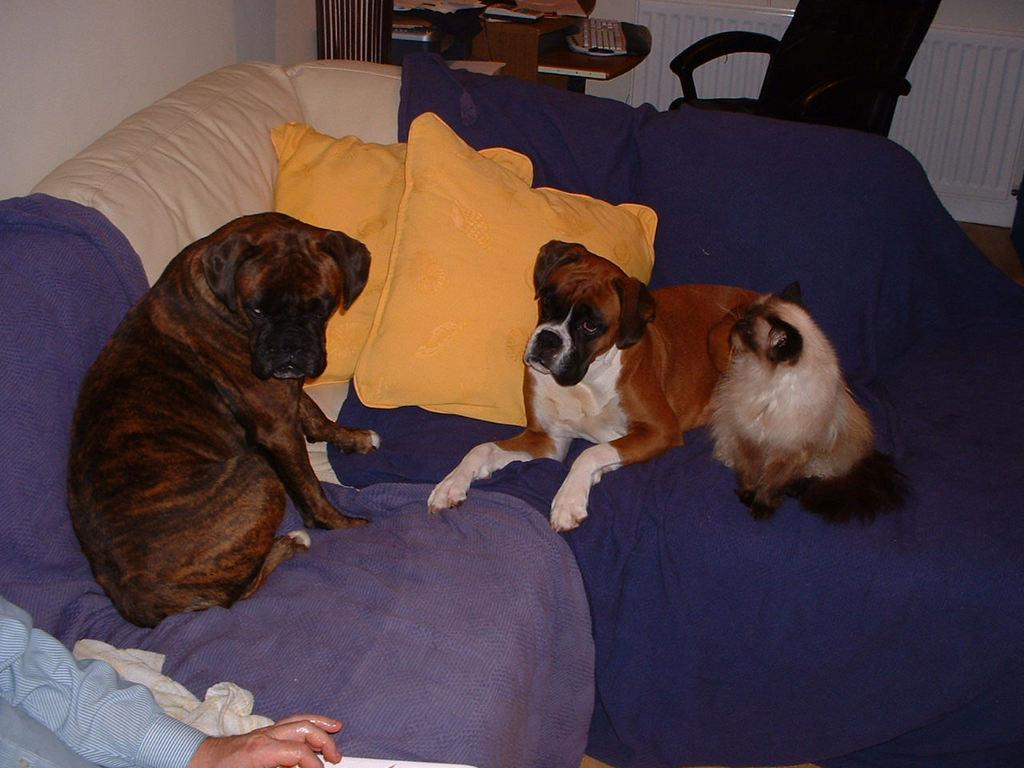What type of furniture is in the image? There is a couch in the image. What is sitting on the couch? Two dogs and a person are sitting on the couch. What is the purpose of the table in the image? The table has many objects on it, suggesting it is used for storage or display. How many trees can be seen in the image? There are no trees visible in the image. What sound does the bell make in the image? There is no bell present in the image. 